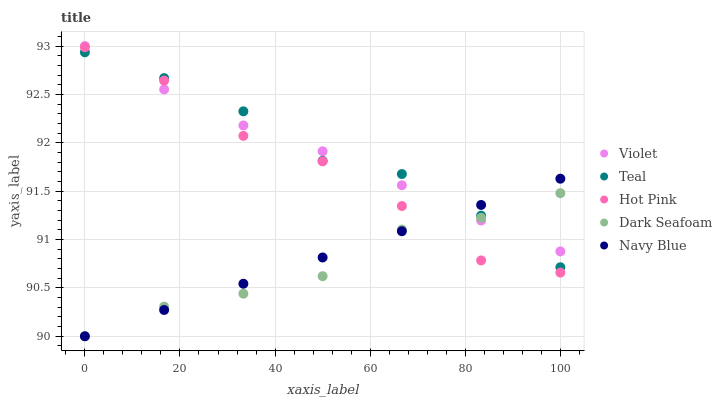Does Dark Seafoam have the minimum area under the curve?
Answer yes or no. Yes. Does Teal have the maximum area under the curve?
Answer yes or no. Yes. Does Hot Pink have the minimum area under the curve?
Answer yes or no. No. Does Hot Pink have the maximum area under the curve?
Answer yes or no. No. Is Navy Blue the smoothest?
Answer yes or no. Yes. Is Hot Pink the roughest?
Answer yes or no. Yes. Is Dark Seafoam the smoothest?
Answer yes or no. No. Is Dark Seafoam the roughest?
Answer yes or no. No. Does Navy Blue have the lowest value?
Answer yes or no. Yes. Does Hot Pink have the lowest value?
Answer yes or no. No. Does Violet have the highest value?
Answer yes or no. Yes. Does Hot Pink have the highest value?
Answer yes or no. No. Does Navy Blue intersect Hot Pink?
Answer yes or no. Yes. Is Navy Blue less than Hot Pink?
Answer yes or no. No. Is Navy Blue greater than Hot Pink?
Answer yes or no. No. 